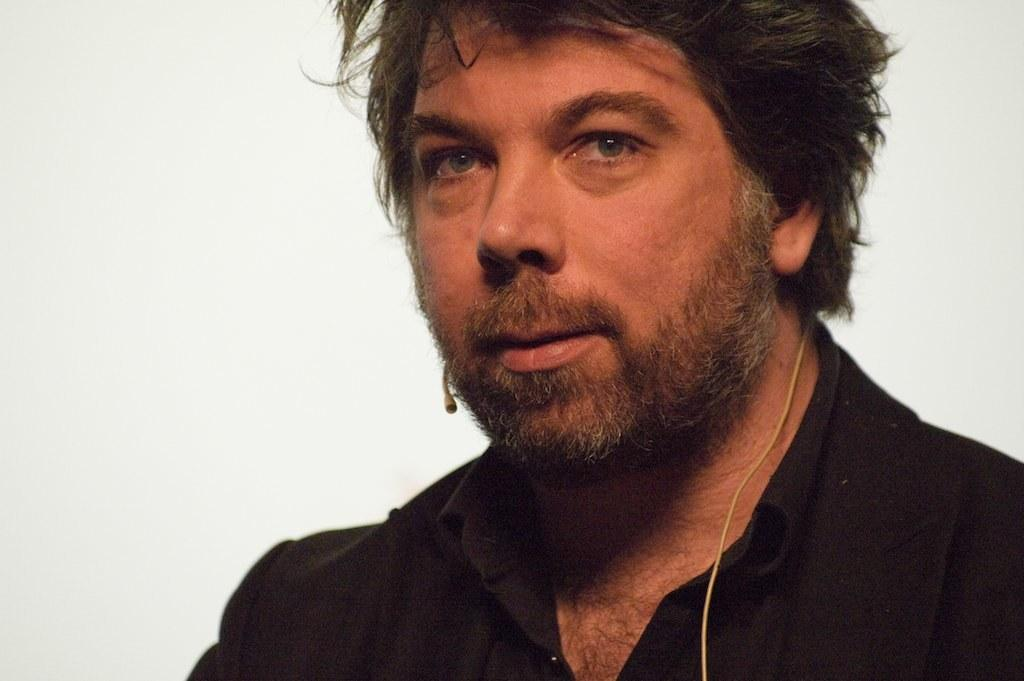What is the main subject of the image? The main subject of the image is a man. What is the man wearing in the image? The man is wearing a black shirt in the image. What can be seen attached to the man's ears? There is a microphone attached to the man's ears in the image. What type of behavior does the man's grandmother exhibit in the image? There is no mention of the man's grandmother in the image, so it is not possible to answer this question. 